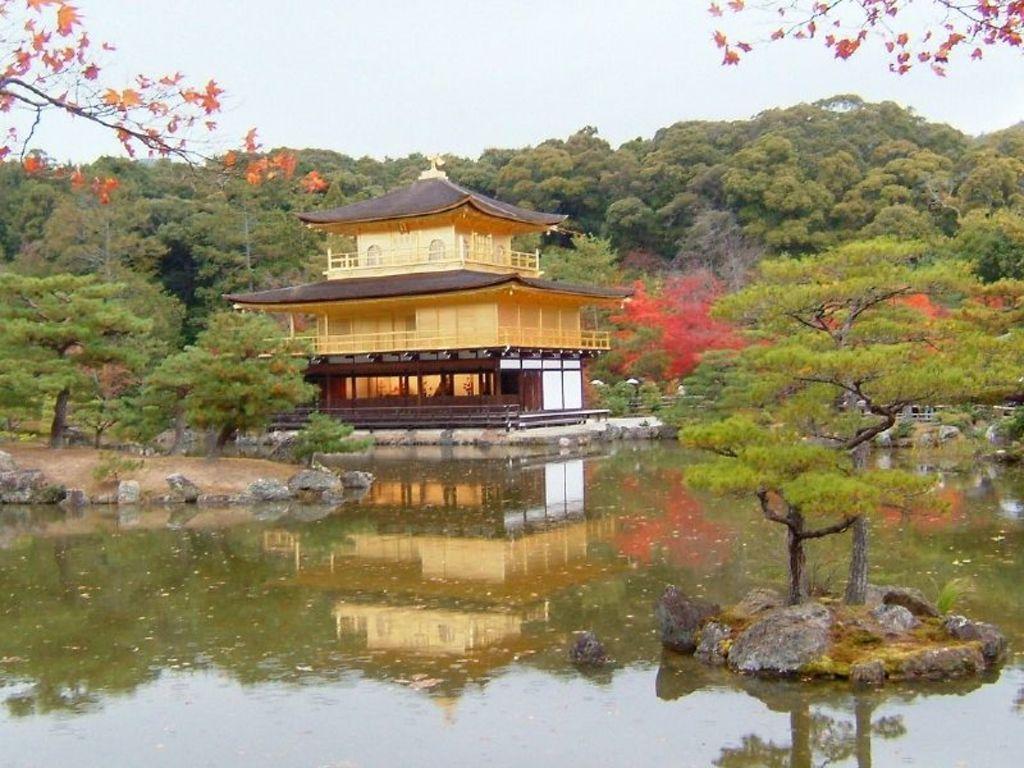In one or two sentences, can you explain what this image depicts? In this image, there is water, there is a yellow and black color house, at the background there are some green color trees, at the top there is a sky. 